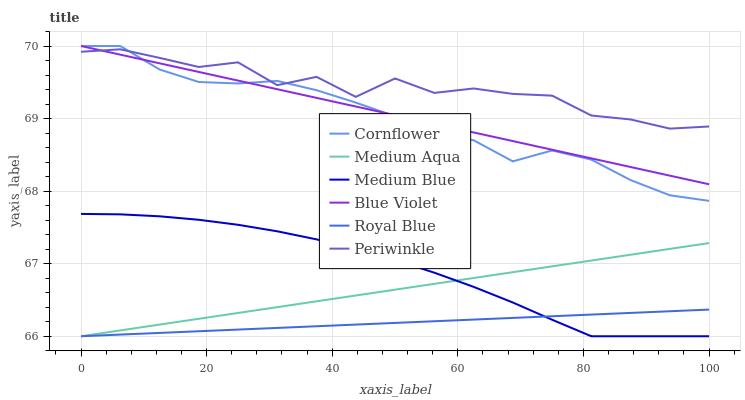Does Royal Blue have the minimum area under the curve?
Answer yes or no. Yes. Does Periwinkle have the maximum area under the curve?
Answer yes or no. Yes. Does Medium Blue have the minimum area under the curve?
Answer yes or no. No. Does Medium Blue have the maximum area under the curve?
Answer yes or no. No. Is Medium Aqua the smoothest?
Answer yes or no. Yes. Is Periwinkle the roughest?
Answer yes or no. Yes. Is Medium Blue the smoothest?
Answer yes or no. No. Is Medium Blue the roughest?
Answer yes or no. No. Does Medium Blue have the lowest value?
Answer yes or no. Yes. Does Periwinkle have the lowest value?
Answer yes or no. No. Does Blue Violet have the highest value?
Answer yes or no. Yes. Does Medium Blue have the highest value?
Answer yes or no. No. Is Medium Aqua less than Periwinkle?
Answer yes or no. Yes. Is Periwinkle greater than Medium Aqua?
Answer yes or no. Yes. Does Medium Aqua intersect Royal Blue?
Answer yes or no. Yes. Is Medium Aqua less than Royal Blue?
Answer yes or no. No. Is Medium Aqua greater than Royal Blue?
Answer yes or no. No. Does Medium Aqua intersect Periwinkle?
Answer yes or no. No. 